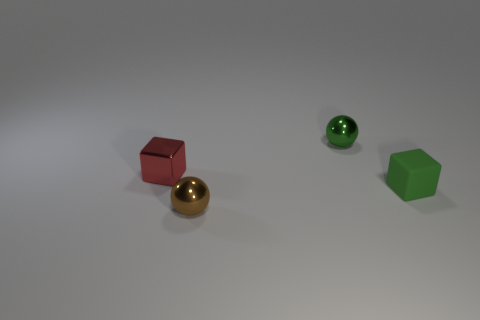Subtract all blue blocks. Subtract all cyan balls. How many blocks are left? 2 Subtract all brown cylinders. How many green cubes are left? 1 Add 4 small browns. How many reds exist? 0 Subtract all tiny green cubes. Subtract all small brown metallic things. How many objects are left? 2 Add 1 small green spheres. How many small green spheres are left? 2 Add 3 red shiny things. How many red shiny things exist? 4 Add 4 large gray objects. How many objects exist? 8 Subtract all red blocks. How many blocks are left? 1 Subtract 0 purple cylinders. How many objects are left? 4 Subtract 1 blocks. How many blocks are left? 1 